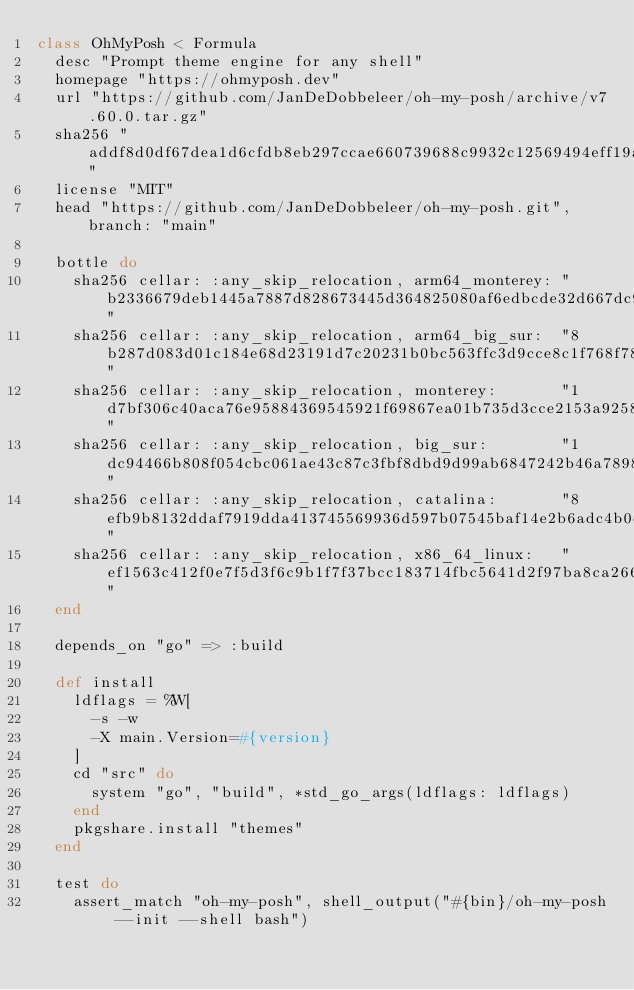Convert code to text. <code><loc_0><loc_0><loc_500><loc_500><_Ruby_>class OhMyPosh < Formula
  desc "Prompt theme engine for any shell"
  homepage "https://ohmyposh.dev"
  url "https://github.com/JanDeDobbeleer/oh-my-posh/archive/v7.60.0.tar.gz"
  sha256 "addf8d0df67dea1d6cfdb8eb297ccae660739688c9932c12569494eff19a14cc"
  license "MIT"
  head "https://github.com/JanDeDobbeleer/oh-my-posh.git", branch: "main"

  bottle do
    sha256 cellar: :any_skip_relocation, arm64_monterey: "b2336679deb1445a7887d828673445d364825080af6edbcde32d667dc9985ea5"
    sha256 cellar: :any_skip_relocation, arm64_big_sur:  "8b287d083d01c184e68d23191d7c20231b0bc563ffc3d9cce8c1f768f78a4a94"
    sha256 cellar: :any_skip_relocation, monterey:       "1d7bf306c40aca76e95884369545921f69867ea01b735d3cce2153a9258d6875"
    sha256 cellar: :any_skip_relocation, big_sur:        "1dc94466b808f054cbc061ae43c87c3fbf8dbd9d99ab6847242b46a7898d865c"
    sha256 cellar: :any_skip_relocation, catalina:       "8efb9b8132ddaf7919dda413745569936d597b07545baf14e2b6adc4b0dcc3c1"
    sha256 cellar: :any_skip_relocation, x86_64_linux:   "ef1563c412f0e7f5d3f6c9b1f7f37bcc183714fbc5641d2f97ba8ca26664cdec"
  end

  depends_on "go" => :build

  def install
    ldflags = %W[
      -s -w
      -X main.Version=#{version}
    ]
    cd "src" do
      system "go", "build", *std_go_args(ldflags: ldflags)
    end
    pkgshare.install "themes"
  end

  test do
    assert_match "oh-my-posh", shell_output("#{bin}/oh-my-posh --init --shell bash")</code> 